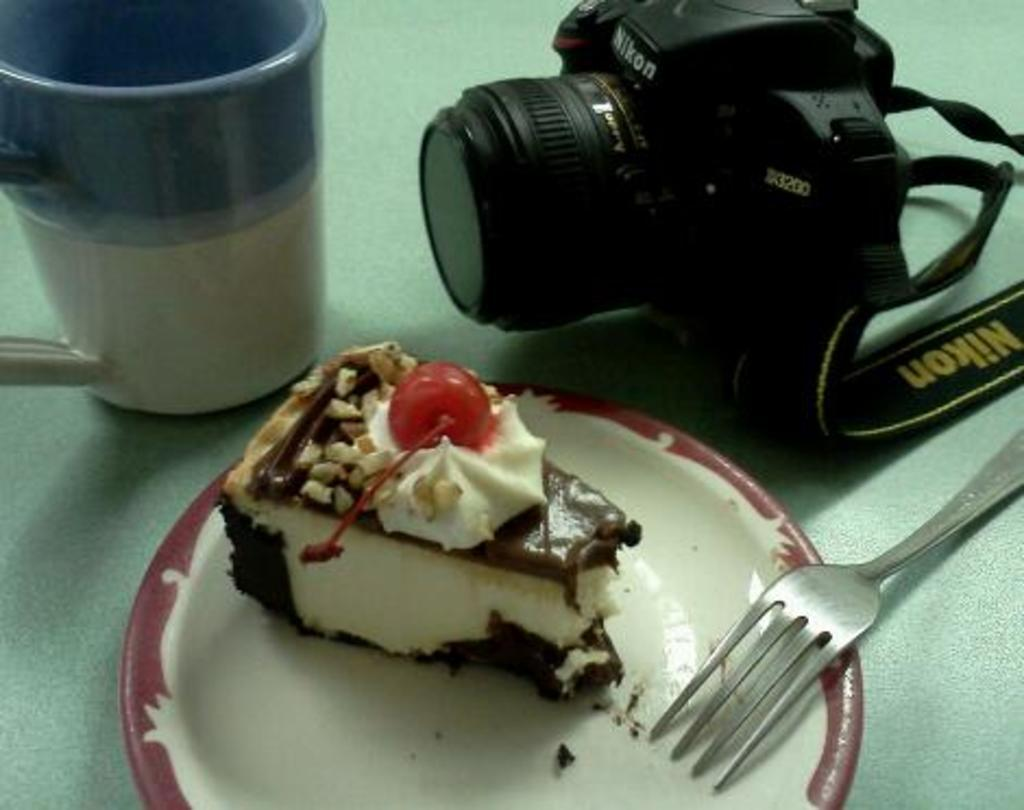What type of food is visible in the image? There is a pastry in the image. Where is the pastry placed? The pastry is on a plate. What utensil can be seen in the image? There is a fork in the image. What beverage container is present in the image? There is a coffee cup in the image. What unrelated object is also visible in the image? There is a camera in the image. What color is the surface in the image? The surface in the image is green. How many toes are visible in the image? There are no toes visible in the image. What type of pie is being served on the plate? There is no pie present in the image; it is a pastry. How many houses can be seen in the background of the image? There is no background or houses visible in the image. 